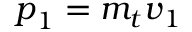<formula> <loc_0><loc_0><loc_500><loc_500>{ p } _ { 1 } = m _ { t } { v } _ { 1 }</formula> 